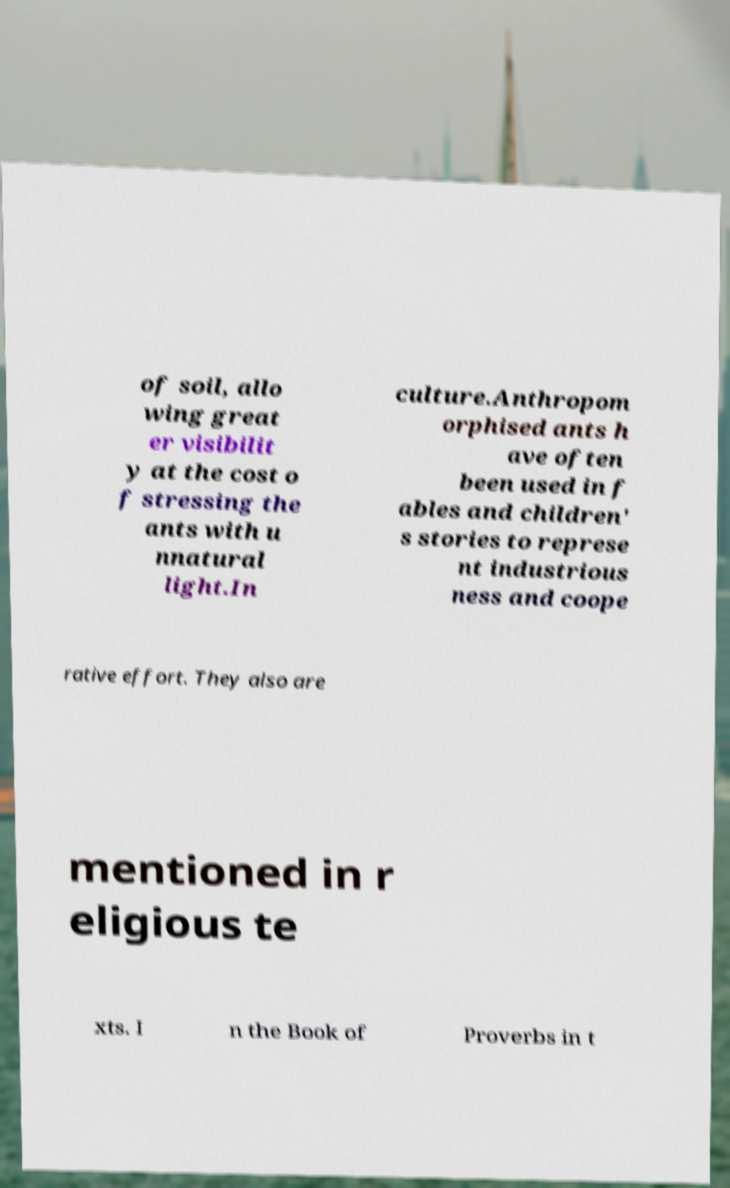For documentation purposes, I need the text within this image transcribed. Could you provide that? of soil, allo wing great er visibilit y at the cost o f stressing the ants with u nnatural light.In culture.Anthropom orphised ants h ave often been used in f ables and children' s stories to represe nt industrious ness and coope rative effort. They also are mentioned in r eligious te xts. I n the Book of Proverbs in t 